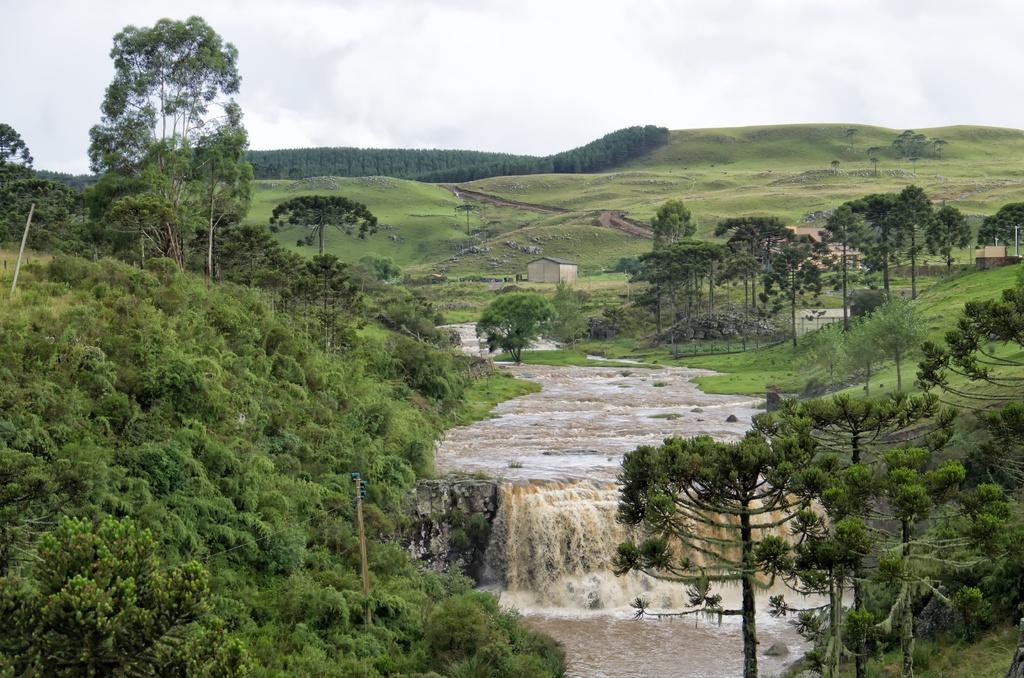What is happening in the foreground of the image? There is water falling in the foreground of the image. What can be seen on either side of the waterfall? There are trees on either side of the waterfall. What type of vegetation is visible in the background of the image? There is grassland visible in the background of the image. What else can be seen in the background of the image? There are there trees and the sky? How many sheep are smashing into the waterfall in the image? There are no sheep present in the image, nor is there any indication of them smashing into the waterfall. 